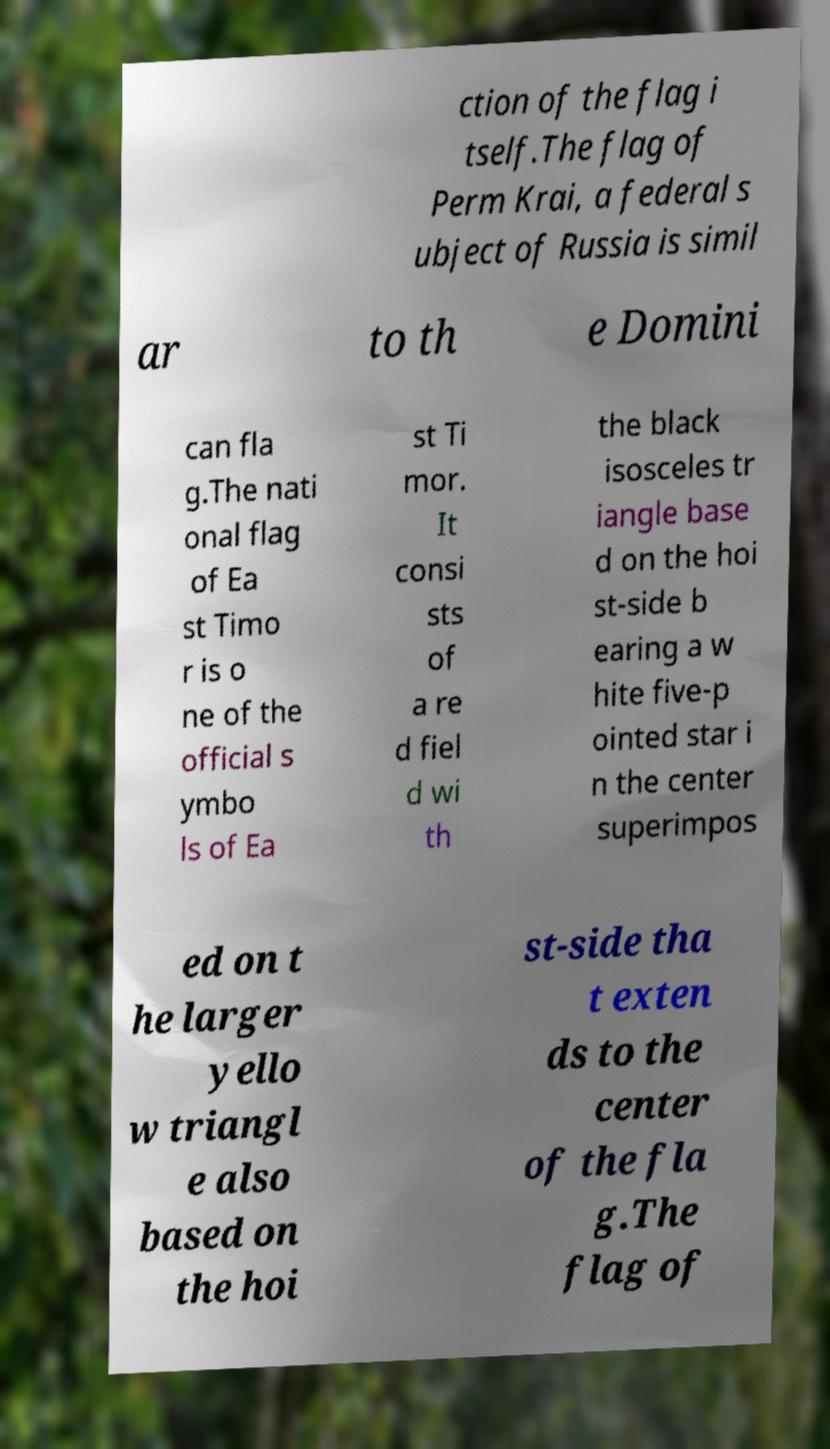Could you extract and type out the text from this image? ction of the flag i tself.The flag of Perm Krai, a federal s ubject of Russia is simil ar to th e Domini can fla g.The nati onal flag of Ea st Timo r is o ne of the official s ymbo ls of Ea st Ti mor. It consi sts of a re d fiel d wi th the black isosceles tr iangle base d on the hoi st-side b earing a w hite five-p ointed star i n the center superimpos ed on t he larger yello w triangl e also based on the hoi st-side tha t exten ds to the center of the fla g.The flag of 